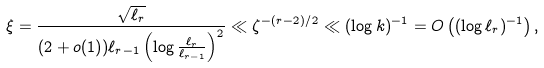<formula> <loc_0><loc_0><loc_500><loc_500>\xi = \frac { \sqrt { \ell _ { r } } } { ( 2 + o ( 1 ) ) \ell _ { r - 1 } \left ( \log \frac { \ell _ { r } } { \ell _ { r - 1 } } \right ) ^ { 2 } } \ll \zeta ^ { - ( r - 2 ) / 2 } \ll ( \log k ) ^ { - 1 } = O \left ( ( \log \ell _ { r } ) ^ { - 1 } \right ) ,</formula> 